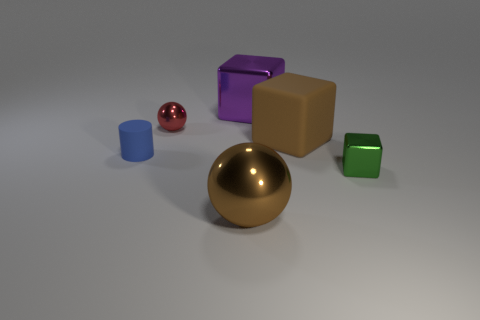Add 2 brown metallic spheres. How many objects exist? 8 Subtract all spheres. How many objects are left? 4 Add 2 shiny balls. How many shiny balls are left? 4 Add 3 big blue blocks. How many big blue blocks exist? 3 Subtract 1 purple cubes. How many objects are left? 5 Subtract all tiny red cubes. Subtract all big balls. How many objects are left? 5 